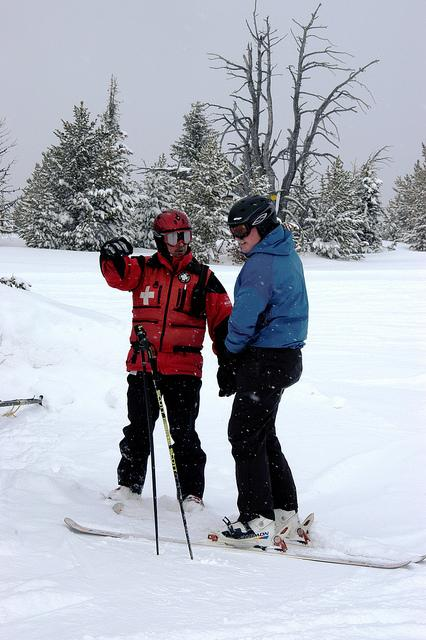What does the man in the red jacket's patch indicate? Please explain your reasoning. emergency personnel. He is an assistance to the player. 